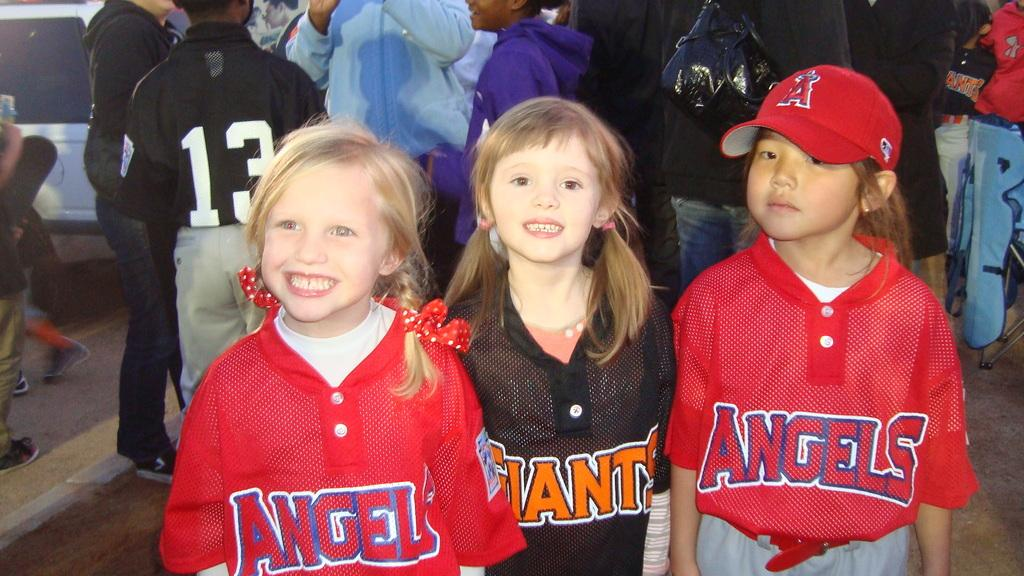<image>
Relay a brief, clear account of the picture shown. Three young girls stand in front of a crowd, two wearing shirts saying "Angels" and one saying "Giants". 